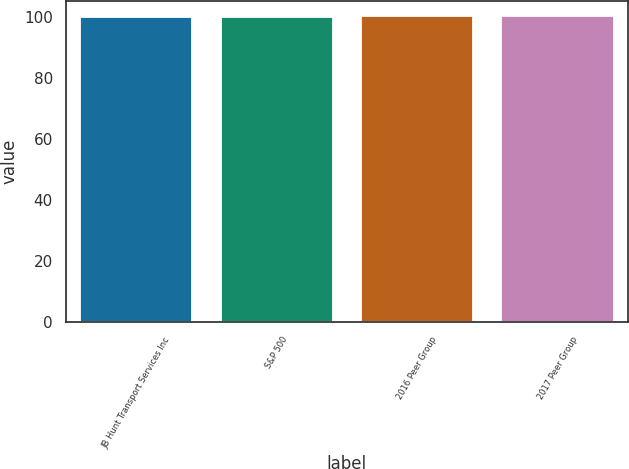<chart> <loc_0><loc_0><loc_500><loc_500><bar_chart><fcel>JB Hunt Transport Services Inc<fcel>S&P 500<fcel>2016 Peer Group<fcel>2017 Peer Group<nl><fcel>100<fcel>100.1<fcel>100.2<fcel>100.3<nl></chart> 